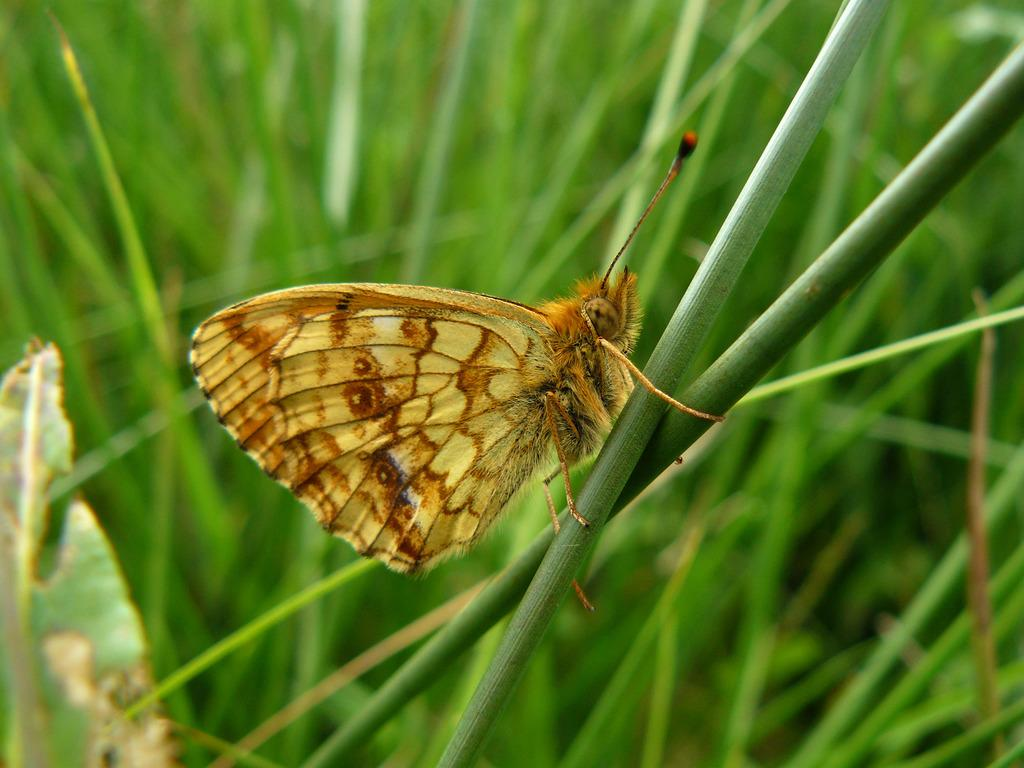What is the main subject of the image? There is a butterfly in the image. Where is the butterfly located? The butterfly is on leaves. Can you describe the background of the image? The background of the image is blurred. What letters can be seen on the rake in the image? There is no rake present in the image, and therefore no letters can be seen on it. 